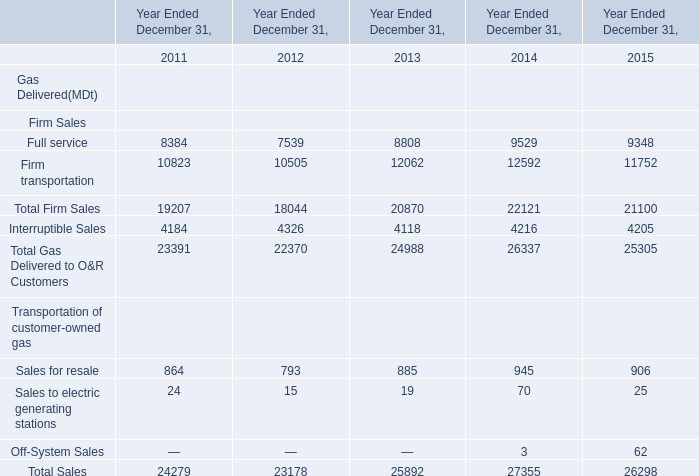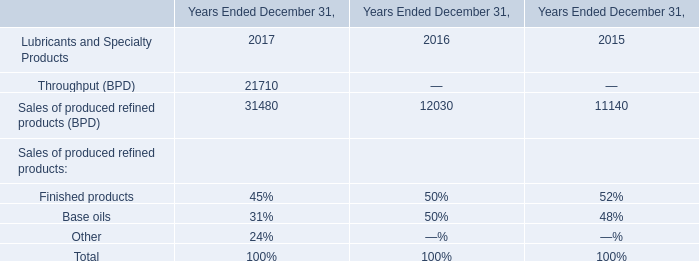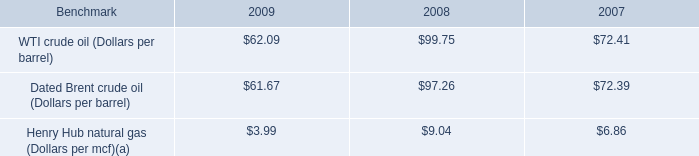by what percentage did the average henry hub natural gas benchmark decrease from 2007 to 2009? 
Computations: ((3.99 - 6.86) / 6.86)
Answer: -0.41837. 